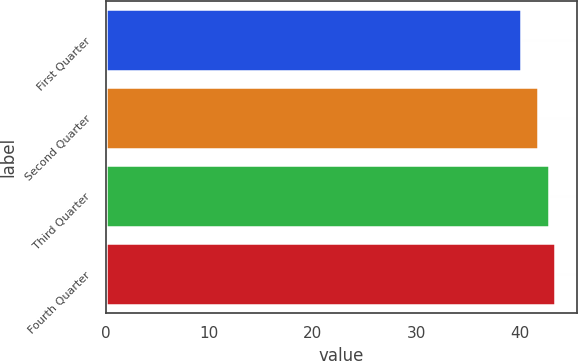Convert chart to OTSL. <chart><loc_0><loc_0><loc_500><loc_500><bar_chart><fcel>First Quarter<fcel>Second Quarter<fcel>Third Quarter<fcel>Fourth Quarter<nl><fcel>40.16<fcel>41.8<fcel>42.86<fcel>43.36<nl></chart> 